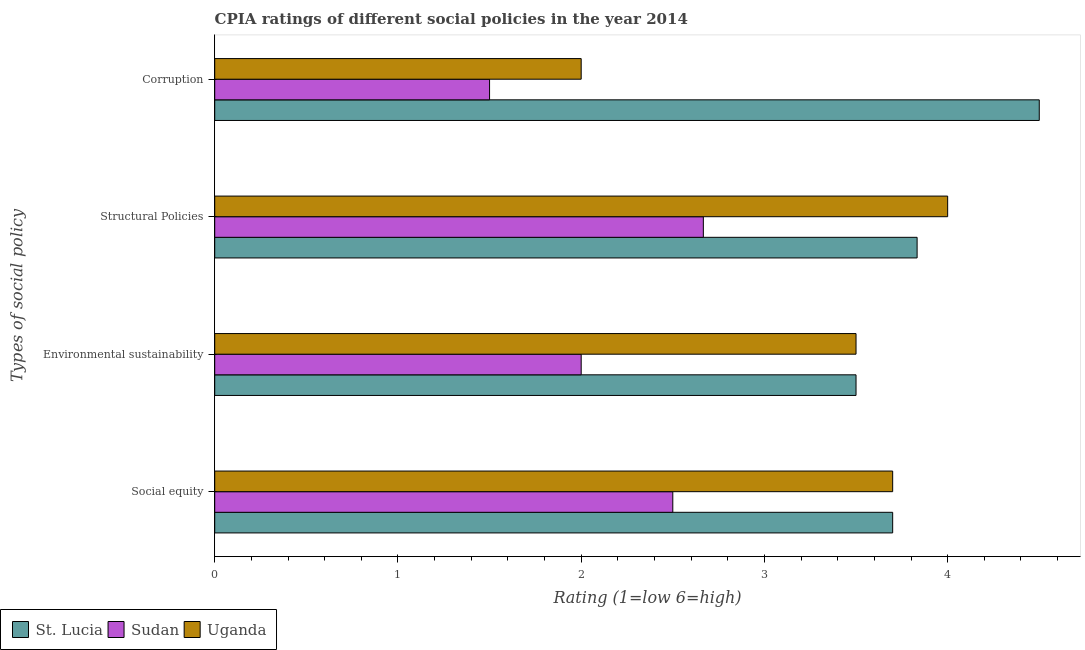How many bars are there on the 4th tick from the bottom?
Your answer should be compact. 3. What is the label of the 1st group of bars from the top?
Keep it short and to the point. Corruption. In which country was the cpia rating of environmental sustainability maximum?
Keep it short and to the point. St. Lucia. In which country was the cpia rating of environmental sustainability minimum?
Ensure brevity in your answer.  Sudan. What is the difference between the cpia rating of structural policies in Uganda and that in Sudan?
Give a very brief answer. 1.33. What is the difference between the cpia rating of social equity in Uganda and the cpia rating of environmental sustainability in Sudan?
Make the answer very short. 1.7. What is the average cpia rating of corruption per country?
Provide a short and direct response. 2.67. What is the difference between the cpia rating of social equity and cpia rating of structural policies in Uganda?
Make the answer very short. -0.3. What is the ratio of the cpia rating of corruption in St. Lucia to that in Uganda?
Your answer should be compact. 2.25. Is the cpia rating of social equity in Uganda less than that in St. Lucia?
Ensure brevity in your answer.  No. What is the difference between the highest and the second highest cpia rating of corruption?
Ensure brevity in your answer.  2.5. Is it the case that in every country, the sum of the cpia rating of structural policies and cpia rating of social equity is greater than the sum of cpia rating of corruption and cpia rating of environmental sustainability?
Ensure brevity in your answer.  No. What does the 1st bar from the top in Corruption represents?
Provide a short and direct response. Uganda. What does the 2nd bar from the bottom in Social equity represents?
Provide a short and direct response. Sudan. Is it the case that in every country, the sum of the cpia rating of social equity and cpia rating of environmental sustainability is greater than the cpia rating of structural policies?
Offer a very short reply. Yes. How many countries are there in the graph?
Ensure brevity in your answer.  3. What is the difference between two consecutive major ticks on the X-axis?
Offer a terse response. 1. Are the values on the major ticks of X-axis written in scientific E-notation?
Provide a succinct answer. No. How are the legend labels stacked?
Your answer should be very brief. Horizontal. What is the title of the graph?
Ensure brevity in your answer.  CPIA ratings of different social policies in the year 2014. What is the label or title of the Y-axis?
Provide a succinct answer. Types of social policy. What is the Rating (1=low 6=high) in Sudan in Social equity?
Offer a terse response. 2.5. What is the Rating (1=low 6=high) of Uganda in Social equity?
Offer a terse response. 3.7. What is the Rating (1=low 6=high) of Sudan in Environmental sustainability?
Offer a terse response. 2. What is the Rating (1=low 6=high) in Uganda in Environmental sustainability?
Your response must be concise. 3.5. What is the Rating (1=low 6=high) in St. Lucia in Structural Policies?
Provide a short and direct response. 3.83. What is the Rating (1=low 6=high) of Sudan in Structural Policies?
Provide a succinct answer. 2.67. What is the Rating (1=low 6=high) of Uganda in Structural Policies?
Provide a short and direct response. 4. What is the Rating (1=low 6=high) of St. Lucia in Corruption?
Provide a short and direct response. 4.5. What is the Rating (1=low 6=high) of Sudan in Corruption?
Provide a succinct answer. 1.5. Across all Types of social policy, what is the maximum Rating (1=low 6=high) in St. Lucia?
Offer a very short reply. 4.5. Across all Types of social policy, what is the maximum Rating (1=low 6=high) of Sudan?
Provide a short and direct response. 2.67. Across all Types of social policy, what is the minimum Rating (1=low 6=high) in Uganda?
Your response must be concise. 2. What is the total Rating (1=low 6=high) of St. Lucia in the graph?
Your response must be concise. 15.53. What is the total Rating (1=low 6=high) of Sudan in the graph?
Provide a succinct answer. 8.67. What is the total Rating (1=low 6=high) in Uganda in the graph?
Your response must be concise. 13.2. What is the difference between the Rating (1=low 6=high) in Sudan in Social equity and that in Environmental sustainability?
Your answer should be compact. 0.5. What is the difference between the Rating (1=low 6=high) of Uganda in Social equity and that in Environmental sustainability?
Keep it short and to the point. 0.2. What is the difference between the Rating (1=low 6=high) of St. Lucia in Social equity and that in Structural Policies?
Provide a short and direct response. -0.13. What is the difference between the Rating (1=low 6=high) of Uganda in Social equity and that in Structural Policies?
Your answer should be very brief. -0.3. What is the difference between the Rating (1=low 6=high) of St. Lucia in Environmental sustainability and that in Structural Policies?
Your response must be concise. -0.33. What is the difference between the Rating (1=low 6=high) in Sudan in Environmental sustainability and that in Structural Policies?
Ensure brevity in your answer.  -0.67. What is the difference between the Rating (1=low 6=high) of Uganda in Environmental sustainability and that in Structural Policies?
Your answer should be very brief. -0.5. What is the difference between the Rating (1=low 6=high) of Uganda in Environmental sustainability and that in Corruption?
Your answer should be very brief. 1.5. What is the difference between the Rating (1=low 6=high) of St. Lucia in Structural Policies and that in Corruption?
Your response must be concise. -0.67. What is the difference between the Rating (1=low 6=high) in Sudan in Structural Policies and that in Corruption?
Ensure brevity in your answer.  1.17. What is the difference between the Rating (1=low 6=high) of Uganda in Structural Policies and that in Corruption?
Provide a succinct answer. 2. What is the difference between the Rating (1=low 6=high) of Sudan in Social equity and the Rating (1=low 6=high) of Uganda in Environmental sustainability?
Ensure brevity in your answer.  -1. What is the difference between the Rating (1=low 6=high) in St. Lucia in Social equity and the Rating (1=low 6=high) in Uganda in Structural Policies?
Your answer should be compact. -0.3. What is the difference between the Rating (1=low 6=high) in Sudan in Social equity and the Rating (1=low 6=high) in Uganda in Structural Policies?
Your answer should be compact. -1.5. What is the difference between the Rating (1=low 6=high) of Sudan in Social equity and the Rating (1=low 6=high) of Uganda in Corruption?
Provide a succinct answer. 0.5. What is the difference between the Rating (1=low 6=high) of St. Lucia in Environmental sustainability and the Rating (1=low 6=high) of Sudan in Structural Policies?
Provide a short and direct response. 0.83. What is the difference between the Rating (1=low 6=high) in St. Lucia in Structural Policies and the Rating (1=low 6=high) in Sudan in Corruption?
Provide a short and direct response. 2.33. What is the difference between the Rating (1=low 6=high) of St. Lucia in Structural Policies and the Rating (1=low 6=high) of Uganda in Corruption?
Offer a very short reply. 1.83. What is the average Rating (1=low 6=high) of St. Lucia per Types of social policy?
Provide a succinct answer. 3.88. What is the average Rating (1=low 6=high) of Sudan per Types of social policy?
Provide a succinct answer. 2.17. What is the average Rating (1=low 6=high) in Uganda per Types of social policy?
Offer a terse response. 3.3. What is the difference between the Rating (1=low 6=high) of St. Lucia and Rating (1=low 6=high) of Sudan in Social equity?
Provide a succinct answer. 1.2. What is the difference between the Rating (1=low 6=high) in St. Lucia and Rating (1=low 6=high) in Uganda in Social equity?
Provide a succinct answer. 0. What is the difference between the Rating (1=low 6=high) of St. Lucia and Rating (1=low 6=high) of Sudan in Environmental sustainability?
Provide a short and direct response. 1.5. What is the difference between the Rating (1=low 6=high) of Sudan and Rating (1=low 6=high) of Uganda in Environmental sustainability?
Ensure brevity in your answer.  -1.5. What is the difference between the Rating (1=low 6=high) in St. Lucia and Rating (1=low 6=high) in Sudan in Structural Policies?
Keep it short and to the point. 1.17. What is the difference between the Rating (1=low 6=high) in Sudan and Rating (1=low 6=high) in Uganda in Structural Policies?
Give a very brief answer. -1.33. What is the difference between the Rating (1=low 6=high) in St. Lucia and Rating (1=low 6=high) in Uganda in Corruption?
Your answer should be compact. 2.5. What is the difference between the Rating (1=low 6=high) in Sudan and Rating (1=low 6=high) in Uganda in Corruption?
Provide a succinct answer. -0.5. What is the ratio of the Rating (1=low 6=high) of St. Lucia in Social equity to that in Environmental sustainability?
Your answer should be compact. 1.06. What is the ratio of the Rating (1=low 6=high) in Sudan in Social equity to that in Environmental sustainability?
Offer a very short reply. 1.25. What is the ratio of the Rating (1=low 6=high) of Uganda in Social equity to that in Environmental sustainability?
Your response must be concise. 1.06. What is the ratio of the Rating (1=low 6=high) in St. Lucia in Social equity to that in Structural Policies?
Make the answer very short. 0.97. What is the ratio of the Rating (1=low 6=high) in Uganda in Social equity to that in Structural Policies?
Offer a terse response. 0.93. What is the ratio of the Rating (1=low 6=high) of St. Lucia in Social equity to that in Corruption?
Offer a terse response. 0.82. What is the ratio of the Rating (1=low 6=high) in Sudan in Social equity to that in Corruption?
Your answer should be compact. 1.67. What is the ratio of the Rating (1=low 6=high) in Uganda in Social equity to that in Corruption?
Your response must be concise. 1.85. What is the ratio of the Rating (1=low 6=high) of Sudan in Environmental sustainability to that in Structural Policies?
Offer a very short reply. 0.75. What is the ratio of the Rating (1=low 6=high) of Uganda in Environmental sustainability to that in Structural Policies?
Offer a very short reply. 0.88. What is the ratio of the Rating (1=low 6=high) of St. Lucia in Environmental sustainability to that in Corruption?
Provide a short and direct response. 0.78. What is the ratio of the Rating (1=low 6=high) of Sudan in Environmental sustainability to that in Corruption?
Keep it short and to the point. 1.33. What is the ratio of the Rating (1=low 6=high) of Uganda in Environmental sustainability to that in Corruption?
Your answer should be very brief. 1.75. What is the ratio of the Rating (1=low 6=high) in St. Lucia in Structural Policies to that in Corruption?
Provide a short and direct response. 0.85. What is the ratio of the Rating (1=low 6=high) of Sudan in Structural Policies to that in Corruption?
Give a very brief answer. 1.78. What is the difference between the highest and the second highest Rating (1=low 6=high) of St. Lucia?
Give a very brief answer. 0.67. What is the difference between the highest and the second highest Rating (1=low 6=high) in Sudan?
Keep it short and to the point. 0.17. What is the difference between the highest and the lowest Rating (1=low 6=high) of Uganda?
Provide a short and direct response. 2. 